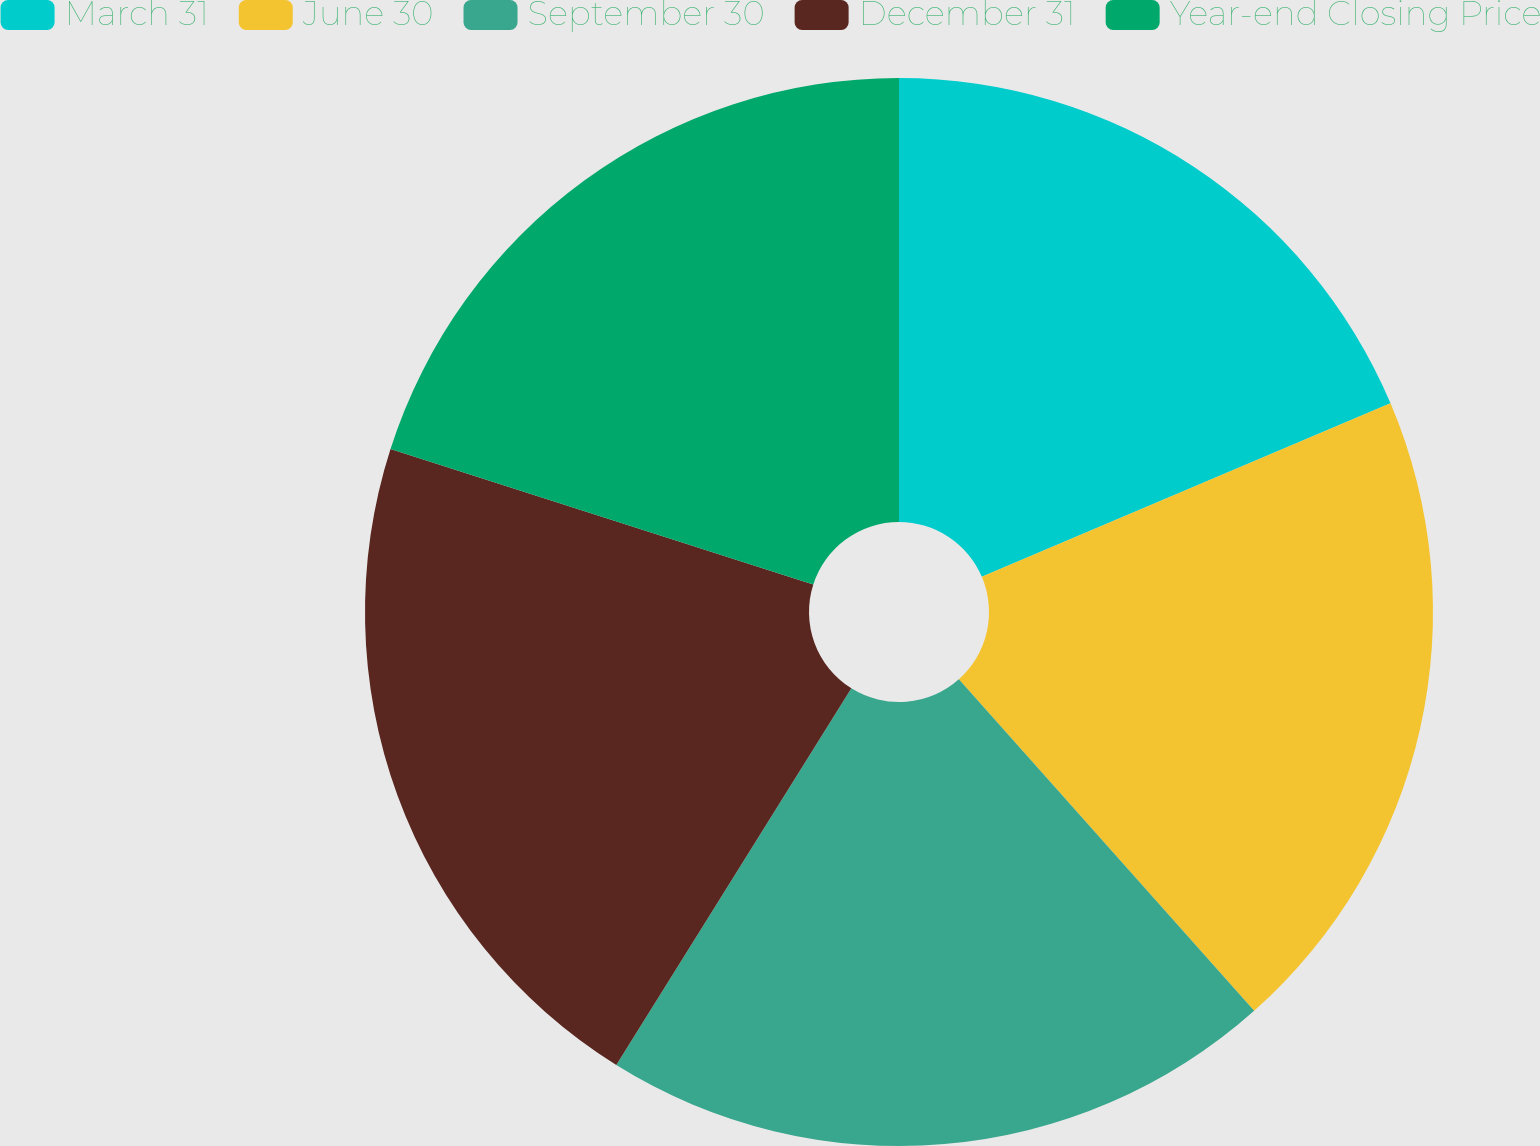Convert chart to OTSL. <chart><loc_0><loc_0><loc_500><loc_500><pie_chart><fcel>March 31<fcel>June 30<fcel>September 30<fcel>December 31<fcel>Year-end Closing Price<nl><fcel>18.61%<fcel>19.81%<fcel>20.46%<fcel>21.06%<fcel>20.06%<nl></chart> 